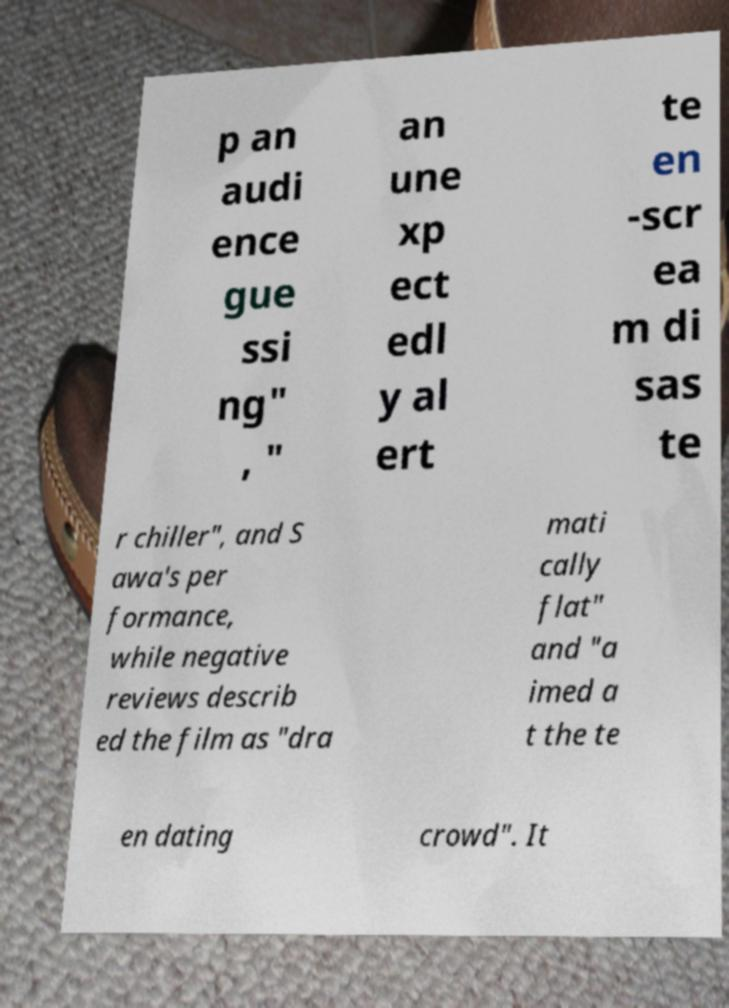I need the written content from this picture converted into text. Can you do that? p an audi ence gue ssi ng" , " an une xp ect edl y al ert te en -scr ea m di sas te r chiller", and S awa's per formance, while negative reviews describ ed the film as "dra mati cally flat" and "a imed a t the te en dating crowd". It 